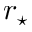<formula> <loc_0><loc_0><loc_500><loc_500>r _ { ^ { * } }</formula> 